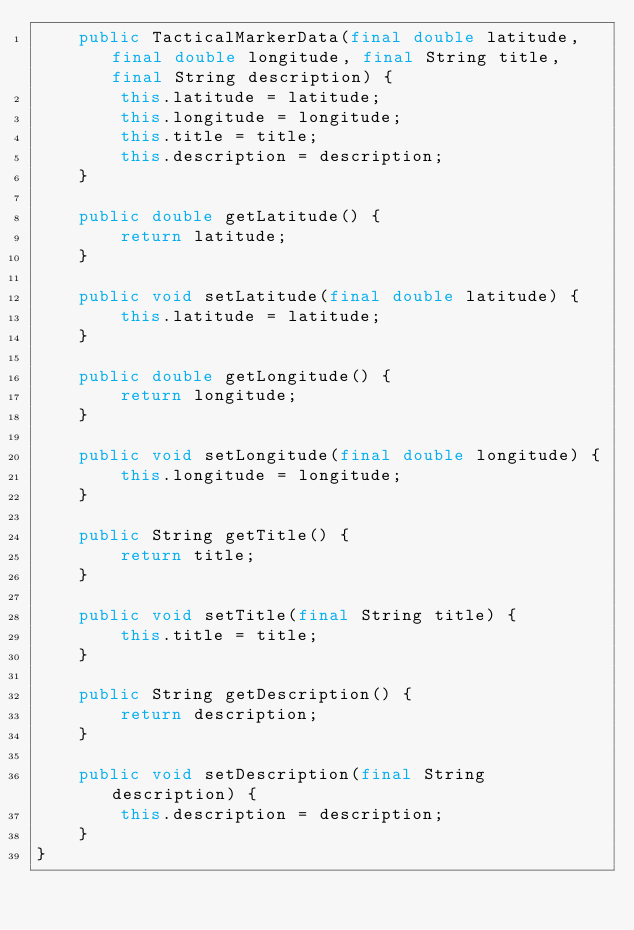Convert code to text. <code><loc_0><loc_0><loc_500><loc_500><_Java_>    public TacticalMarkerData(final double latitude, final double longitude, final String title, final String description) {
        this.latitude = latitude;
        this.longitude = longitude;
        this.title = title;
        this.description = description;
    }

    public double getLatitude() {
        return latitude;
    }

    public void setLatitude(final double latitude) {
        this.latitude = latitude;
    }

    public double getLongitude() {
        return longitude;
    }

    public void setLongitude(final double longitude) {
        this.longitude = longitude;
    }

    public String getTitle() {
        return title;
    }

    public void setTitle(final String title) {
        this.title = title;
    }

    public String getDescription() {
        return description;
    }

    public void setDescription(final String description) {
        this.description = description;
    }
}
</code> 